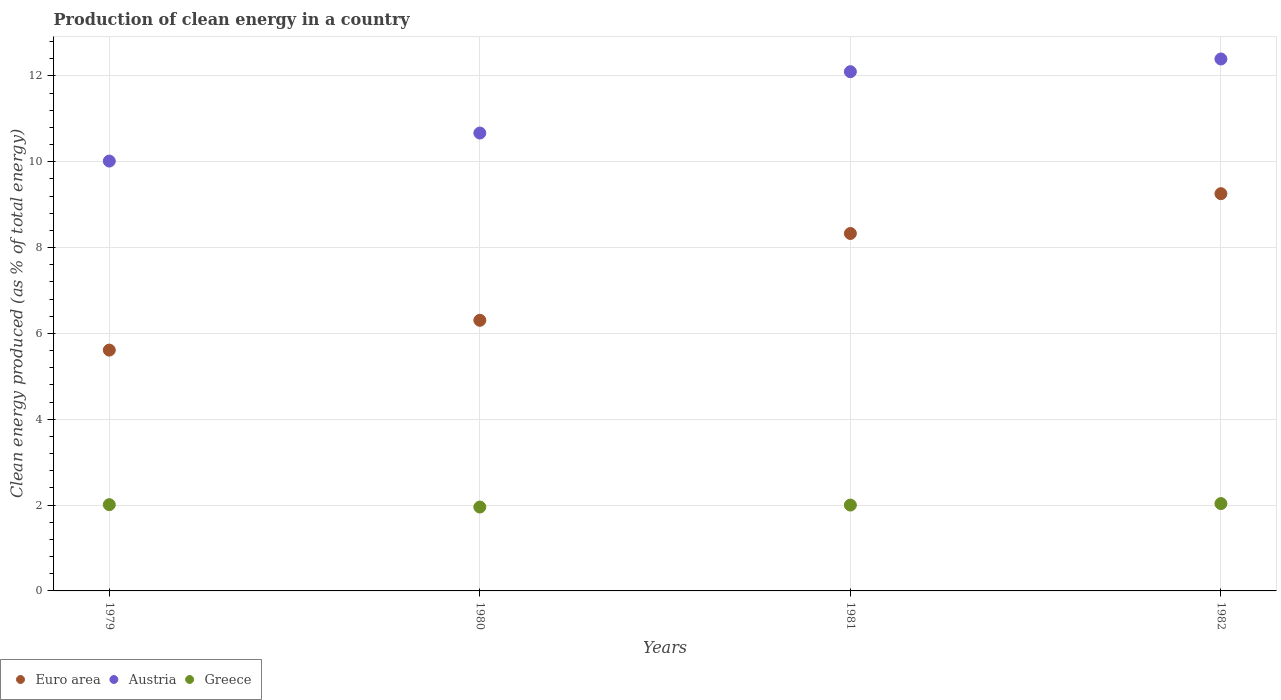How many different coloured dotlines are there?
Ensure brevity in your answer.  3. Is the number of dotlines equal to the number of legend labels?
Offer a terse response. Yes. What is the percentage of clean energy produced in Austria in 1981?
Provide a short and direct response. 12.1. Across all years, what is the maximum percentage of clean energy produced in Greece?
Give a very brief answer. 2.03. Across all years, what is the minimum percentage of clean energy produced in Greece?
Your answer should be compact. 1.95. What is the total percentage of clean energy produced in Austria in the graph?
Offer a terse response. 45.18. What is the difference between the percentage of clean energy produced in Austria in 1980 and that in 1981?
Provide a succinct answer. -1.43. What is the difference between the percentage of clean energy produced in Austria in 1979 and the percentage of clean energy produced in Euro area in 1982?
Your response must be concise. 0.76. What is the average percentage of clean energy produced in Greece per year?
Provide a succinct answer. 2. In the year 1982, what is the difference between the percentage of clean energy produced in Greece and percentage of clean energy produced in Euro area?
Your answer should be very brief. -7.22. What is the ratio of the percentage of clean energy produced in Greece in 1979 to that in 1980?
Your answer should be compact. 1.03. Is the percentage of clean energy produced in Euro area in 1979 less than that in 1980?
Give a very brief answer. Yes. What is the difference between the highest and the second highest percentage of clean energy produced in Euro area?
Offer a very short reply. 0.93. What is the difference between the highest and the lowest percentage of clean energy produced in Greece?
Offer a very short reply. 0.08. In how many years, is the percentage of clean energy produced in Euro area greater than the average percentage of clean energy produced in Euro area taken over all years?
Ensure brevity in your answer.  2. Is the sum of the percentage of clean energy produced in Euro area in 1979 and 1982 greater than the maximum percentage of clean energy produced in Greece across all years?
Offer a terse response. Yes. Is the percentage of clean energy produced in Greece strictly less than the percentage of clean energy produced in Euro area over the years?
Make the answer very short. Yes. How many dotlines are there?
Offer a terse response. 3. How many years are there in the graph?
Keep it short and to the point. 4. Are the values on the major ticks of Y-axis written in scientific E-notation?
Provide a succinct answer. No. Does the graph contain grids?
Your answer should be very brief. Yes. What is the title of the graph?
Give a very brief answer. Production of clean energy in a country. What is the label or title of the Y-axis?
Provide a short and direct response. Clean energy produced (as % of total energy). What is the Clean energy produced (as % of total energy) in Euro area in 1979?
Your answer should be very brief. 5.61. What is the Clean energy produced (as % of total energy) in Austria in 1979?
Your response must be concise. 10.02. What is the Clean energy produced (as % of total energy) in Greece in 1979?
Give a very brief answer. 2.01. What is the Clean energy produced (as % of total energy) of Euro area in 1980?
Offer a terse response. 6.31. What is the Clean energy produced (as % of total energy) in Austria in 1980?
Your answer should be compact. 10.67. What is the Clean energy produced (as % of total energy) in Greece in 1980?
Keep it short and to the point. 1.95. What is the Clean energy produced (as % of total energy) of Euro area in 1981?
Give a very brief answer. 8.33. What is the Clean energy produced (as % of total energy) in Austria in 1981?
Make the answer very short. 12.1. What is the Clean energy produced (as % of total energy) of Greece in 1981?
Make the answer very short. 2. What is the Clean energy produced (as % of total energy) in Euro area in 1982?
Make the answer very short. 9.26. What is the Clean energy produced (as % of total energy) of Austria in 1982?
Your answer should be compact. 12.4. What is the Clean energy produced (as % of total energy) of Greece in 1982?
Give a very brief answer. 2.03. Across all years, what is the maximum Clean energy produced (as % of total energy) of Euro area?
Your answer should be compact. 9.26. Across all years, what is the maximum Clean energy produced (as % of total energy) of Austria?
Offer a terse response. 12.4. Across all years, what is the maximum Clean energy produced (as % of total energy) in Greece?
Offer a very short reply. 2.03. Across all years, what is the minimum Clean energy produced (as % of total energy) of Euro area?
Give a very brief answer. 5.61. Across all years, what is the minimum Clean energy produced (as % of total energy) in Austria?
Your answer should be compact. 10.02. Across all years, what is the minimum Clean energy produced (as % of total energy) of Greece?
Make the answer very short. 1.95. What is the total Clean energy produced (as % of total energy) of Euro area in the graph?
Offer a very short reply. 29.5. What is the total Clean energy produced (as % of total energy) in Austria in the graph?
Offer a very short reply. 45.18. What is the total Clean energy produced (as % of total energy) in Greece in the graph?
Ensure brevity in your answer.  8. What is the difference between the Clean energy produced (as % of total energy) of Euro area in 1979 and that in 1980?
Your response must be concise. -0.69. What is the difference between the Clean energy produced (as % of total energy) in Austria in 1979 and that in 1980?
Provide a short and direct response. -0.65. What is the difference between the Clean energy produced (as % of total energy) of Greece in 1979 and that in 1980?
Offer a very short reply. 0.06. What is the difference between the Clean energy produced (as % of total energy) of Euro area in 1979 and that in 1981?
Make the answer very short. -2.72. What is the difference between the Clean energy produced (as % of total energy) of Austria in 1979 and that in 1981?
Provide a succinct answer. -2.08. What is the difference between the Clean energy produced (as % of total energy) in Greece in 1979 and that in 1981?
Offer a very short reply. 0.01. What is the difference between the Clean energy produced (as % of total energy) of Euro area in 1979 and that in 1982?
Provide a succinct answer. -3.64. What is the difference between the Clean energy produced (as % of total energy) of Austria in 1979 and that in 1982?
Provide a short and direct response. -2.38. What is the difference between the Clean energy produced (as % of total energy) in Greece in 1979 and that in 1982?
Your answer should be compact. -0.03. What is the difference between the Clean energy produced (as % of total energy) in Euro area in 1980 and that in 1981?
Keep it short and to the point. -2.02. What is the difference between the Clean energy produced (as % of total energy) of Austria in 1980 and that in 1981?
Your response must be concise. -1.43. What is the difference between the Clean energy produced (as % of total energy) of Greece in 1980 and that in 1981?
Your answer should be very brief. -0.05. What is the difference between the Clean energy produced (as % of total energy) in Euro area in 1980 and that in 1982?
Your answer should be very brief. -2.95. What is the difference between the Clean energy produced (as % of total energy) of Austria in 1980 and that in 1982?
Offer a terse response. -1.73. What is the difference between the Clean energy produced (as % of total energy) of Greece in 1980 and that in 1982?
Offer a terse response. -0.08. What is the difference between the Clean energy produced (as % of total energy) in Euro area in 1981 and that in 1982?
Your answer should be very brief. -0.93. What is the difference between the Clean energy produced (as % of total energy) of Austria in 1981 and that in 1982?
Provide a succinct answer. -0.3. What is the difference between the Clean energy produced (as % of total energy) of Greece in 1981 and that in 1982?
Provide a short and direct response. -0.03. What is the difference between the Clean energy produced (as % of total energy) of Euro area in 1979 and the Clean energy produced (as % of total energy) of Austria in 1980?
Make the answer very short. -5.06. What is the difference between the Clean energy produced (as % of total energy) in Euro area in 1979 and the Clean energy produced (as % of total energy) in Greece in 1980?
Provide a short and direct response. 3.66. What is the difference between the Clean energy produced (as % of total energy) in Austria in 1979 and the Clean energy produced (as % of total energy) in Greece in 1980?
Provide a succinct answer. 8.06. What is the difference between the Clean energy produced (as % of total energy) of Euro area in 1979 and the Clean energy produced (as % of total energy) of Austria in 1981?
Give a very brief answer. -6.49. What is the difference between the Clean energy produced (as % of total energy) in Euro area in 1979 and the Clean energy produced (as % of total energy) in Greece in 1981?
Offer a terse response. 3.61. What is the difference between the Clean energy produced (as % of total energy) of Austria in 1979 and the Clean energy produced (as % of total energy) of Greece in 1981?
Give a very brief answer. 8.02. What is the difference between the Clean energy produced (as % of total energy) in Euro area in 1979 and the Clean energy produced (as % of total energy) in Austria in 1982?
Make the answer very short. -6.78. What is the difference between the Clean energy produced (as % of total energy) in Euro area in 1979 and the Clean energy produced (as % of total energy) in Greece in 1982?
Provide a short and direct response. 3.58. What is the difference between the Clean energy produced (as % of total energy) in Austria in 1979 and the Clean energy produced (as % of total energy) in Greece in 1982?
Your response must be concise. 7.98. What is the difference between the Clean energy produced (as % of total energy) of Euro area in 1980 and the Clean energy produced (as % of total energy) of Austria in 1981?
Provide a short and direct response. -5.79. What is the difference between the Clean energy produced (as % of total energy) in Euro area in 1980 and the Clean energy produced (as % of total energy) in Greece in 1981?
Ensure brevity in your answer.  4.31. What is the difference between the Clean energy produced (as % of total energy) of Austria in 1980 and the Clean energy produced (as % of total energy) of Greece in 1981?
Keep it short and to the point. 8.67. What is the difference between the Clean energy produced (as % of total energy) of Euro area in 1980 and the Clean energy produced (as % of total energy) of Austria in 1982?
Offer a very short reply. -6.09. What is the difference between the Clean energy produced (as % of total energy) of Euro area in 1980 and the Clean energy produced (as % of total energy) of Greece in 1982?
Provide a succinct answer. 4.27. What is the difference between the Clean energy produced (as % of total energy) of Austria in 1980 and the Clean energy produced (as % of total energy) of Greece in 1982?
Your answer should be very brief. 8.63. What is the difference between the Clean energy produced (as % of total energy) in Euro area in 1981 and the Clean energy produced (as % of total energy) in Austria in 1982?
Provide a short and direct response. -4.07. What is the difference between the Clean energy produced (as % of total energy) of Euro area in 1981 and the Clean energy produced (as % of total energy) of Greece in 1982?
Keep it short and to the point. 6.29. What is the difference between the Clean energy produced (as % of total energy) of Austria in 1981 and the Clean energy produced (as % of total energy) of Greece in 1982?
Your answer should be very brief. 10.06. What is the average Clean energy produced (as % of total energy) in Euro area per year?
Give a very brief answer. 7.38. What is the average Clean energy produced (as % of total energy) of Austria per year?
Provide a succinct answer. 11.29. What is the average Clean energy produced (as % of total energy) of Greece per year?
Your answer should be compact. 2. In the year 1979, what is the difference between the Clean energy produced (as % of total energy) of Euro area and Clean energy produced (as % of total energy) of Austria?
Offer a terse response. -4.4. In the year 1979, what is the difference between the Clean energy produced (as % of total energy) in Euro area and Clean energy produced (as % of total energy) in Greece?
Your answer should be compact. 3.6. In the year 1979, what is the difference between the Clean energy produced (as % of total energy) of Austria and Clean energy produced (as % of total energy) of Greece?
Make the answer very short. 8.01. In the year 1980, what is the difference between the Clean energy produced (as % of total energy) in Euro area and Clean energy produced (as % of total energy) in Austria?
Offer a terse response. -4.36. In the year 1980, what is the difference between the Clean energy produced (as % of total energy) of Euro area and Clean energy produced (as % of total energy) of Greece?
Keep it short and to the point. 4.35. In the year 1980, what is the difference between the Clean energy produced (as % of total energy) in Austria and Clean energy produced (as % of total energy) in Greece?
Your response must be concise. 8.71. In the year 1981, what is the difference between the Clean energy produced (as % of total energy) in Euro area and Clean energy produced (as % of total energy) in Austria?
Offer a terse response. -3.77. In the year 1981, what is the difference between the Clean energy produced (as % of total energy) in Euro area and Clean energy produced (as % of total energy) in Greece?
Offer a very short reply. 6.33. In the year 1981, what is the difference between the Clean energy produced (as % of total energy) in Austria and Clean energy produced (as % of total energy) in Greece?
Provide a succinct answer. 10.1. In the year 1982, what is the difference between the Clean energy produced (as % of total energy) of Euro area and Clean energy produced (as % of total energy) of Austria?
Offer a terse response. -3.14. In the year 1982, what is the difference between the Clean energy produced (as % of total energy) of Euro area and Clean energy produced (as % of total energy) of Greece?
Keep it short and to the point. 7.22. In the year 1982, what is the difference between the Clean energy produced (as % of total energy) of Austria and Clean energy produced (as % of total energy) of Greece?
Offer a very short reply. 10.36. What is the ratio of the Clean energy produced (as % of total energy) of Euro area in 1979 to that in 1980?
Give a very brief answer. 0.89. What is the ratio of the Clean energy produced (as % of total energy) in Austria in 1979 to that in 1980?
Provide a short and direct response. 0.94. What is the ratio of the Clean energy produced (as % of total energy) in Greece in 1979 to that in 1980?
Offer a terse response. 1.03. What is the ratio of the Clean energy produced (as % of total energy) in Euro area in 1979 to that in 1981?
Give a very brief answer. 0.67. What is the ratio of the Clean energy produced (as % of total energy) of Austria in 1979 to that in 1981?
Ensure brevity in your answer.  0.83. What is the ratio of the Clean energy produced (as % of total energy) of Euro area in 1979 to that in 1982?
Keep it short and to the point. 0.61. What is the ratio of the Clean energy produced (as % of total energy) in Austria in 1979 to that in 1982?
Keep it short and to the point. 0.81. What is the ratio of the Clean energy produced (as % of total energy) of Euro area in 1980 to that in 1981?
Offer a terse response. 0.76. What is the ratio of the Clean energy produced (as % of total energy) in Austria in 1980 to that in 1981?
Your answer should be very brief. 0.88. What is the ratio of the Clean energy produced (as % of total energy) in Greece in 1980 to that in 1981?
Your response must be concise. 0.98. What is the ratio of the Clean energy produced (as % of total energy) of Euro area in 1980 to that in 1982?
Provide a succinct answer. 0.68. What is the ratio of the Clean energy produced (as % of total energy) in Austria in 1980 to that in 1982?
Your answer should be very brief. 0.86. What is the ratio of the Clean energy produced (as % of total energy) in Greece in 1980 to that in 1982?
Offer a very short reply. 0.96. What is the ratio of the Clean energy produced (as % of total energy) of Euro area in 1981 to that in 1982?
Provide a short and direct response. 0.9. What is the ratio of the Clean energy produced (as % of total energy) of Austria in 1981 to that in 1982?
Your response must be concise. 0.98. What is the ratio of the Clean energy produced (as % of total energy) of Greece in 1981 to that in 1982?
Your answer should be compact. 0.98. What is the difference between the highest and the second highest Clean energy produced (as % of total energy) in Euro area?
Provide a short and direct response. 0.93. What is the difference between the highest and the second highest Clean energy produced (as % of total energy) in Austria?
Your answer should be very brief. 0.3. What is the difference between the highest and the second highest Clean energy produced (as % of total energy) of Greece?
Keep it short and to the point. 0.03. What is the difference between the highest and the lowest Clean energy produced (as % of total energy) in Euro area?
Keep it short and to the point. 3.64. What is the difference between the highest and the lowest Clean energy produced (as % of total energy) of Austria?
Make the answer very short. 2.38. What is the difference between the highest and the lowest Clean energy produced (as % of total energy) of Greece?
Give a very brief answer. 0.08. 